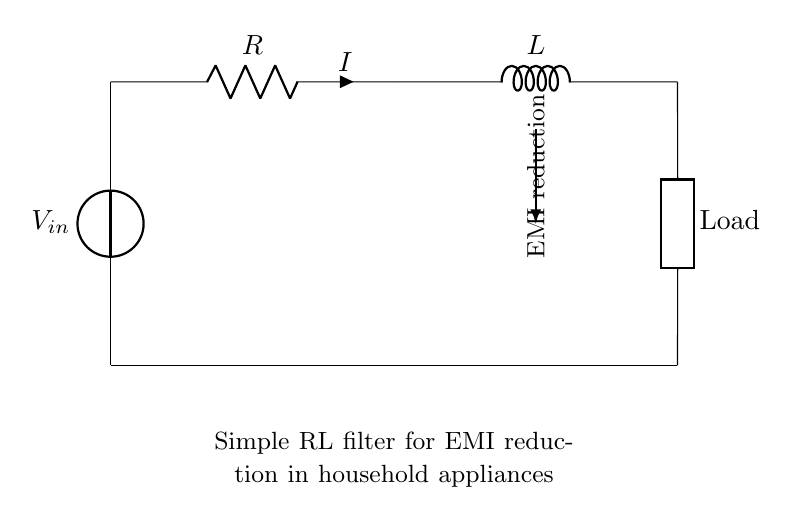What is the input voltage in the circuit? The input voltage is represented by \( V_{in} \) in the circuit. There are no specific values given, but it is labeled clearly at the top of the diagram.
Answer: \( V_{in} \) What components are used in this RL filter circuit? The circuit consists of a voltage source, a resistor labeled \( R \), an inductor labeled \( L \), and a generic load. Each component is clearly labeled in the diagram.
Answer: Voltage source, resistor, inductor, load What is the purpose of the inductor in this circuit? The inductor is used to reduce electromagnetic interference (EMI). It creates a magnetic field that opposes rapid changes in current, thereby smoothing out fluctuations caused by EMI.
Answer: EMI reduction How does current flow in this circuit? Current flows from the voltage source through the resistor, then through the inductor, and finally to the load. This series connection allows the inductor to affect the current based on its inductive reactance.
Answer: From voltage source to load What effect does the resistor have in the circuit? The resistor limits the amount of current flowing through the circuit. It also contributes to the loss of energy in the form of heat, which can help dampen high-frequency signals contributing to EMI.
Answer: Current limiting How does the circuit reduce electromagnetic interference? The RL filter reduces electromagnetic interference by using the inductor to store energy in its magnetic field, thereby filtering out high-frequency noise signals and allowing the desired ones to pass more smoothly.
Answer: Filtering high-frequency noise 